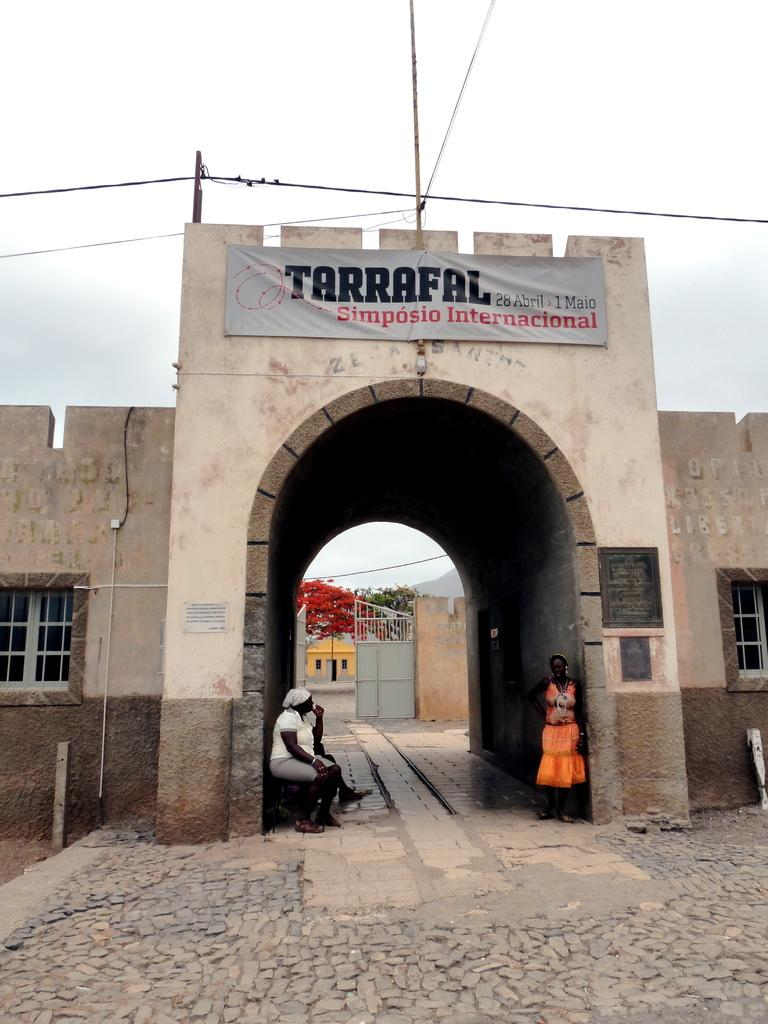How many people are present in the image? There are two people in the image, one sitting and one standing. What can be seen in the background of the image? There is a house, a gate, trees, and the sky visible in the background of the image. What is attached to the wall in the image? There is a banner on a wall in the image. Are there any wires visible in the image? Yes, there are wires visible in the image. Can you describe the window in the image? There is a window in the image, but its specific features are not mentioned in the facts. How many flowers are being used as a hat by the beetle in the image? There is no beetle or flowers present in the image. What type of hole can be seen in the image? There is no hole present in the image. 